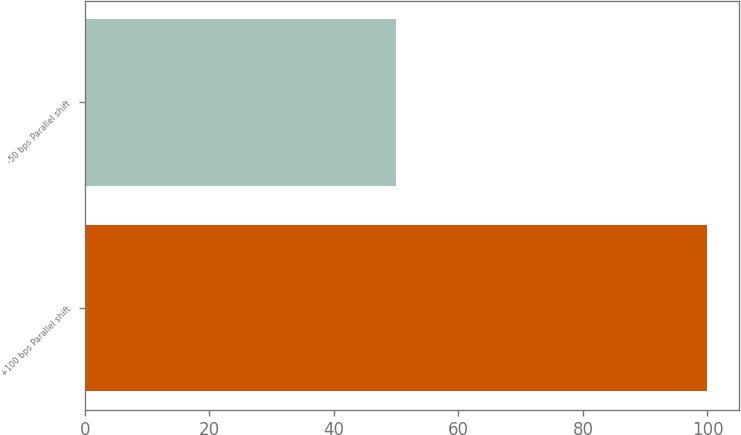Convert chart. <chart><loc_0><loc_0><loc_500><loc_500><bar_chart><fcel>+100 bps Parallel shift<fcel>-50 bps Parallel shift<nl><fcel>100<fcel>50<nl></chart> 